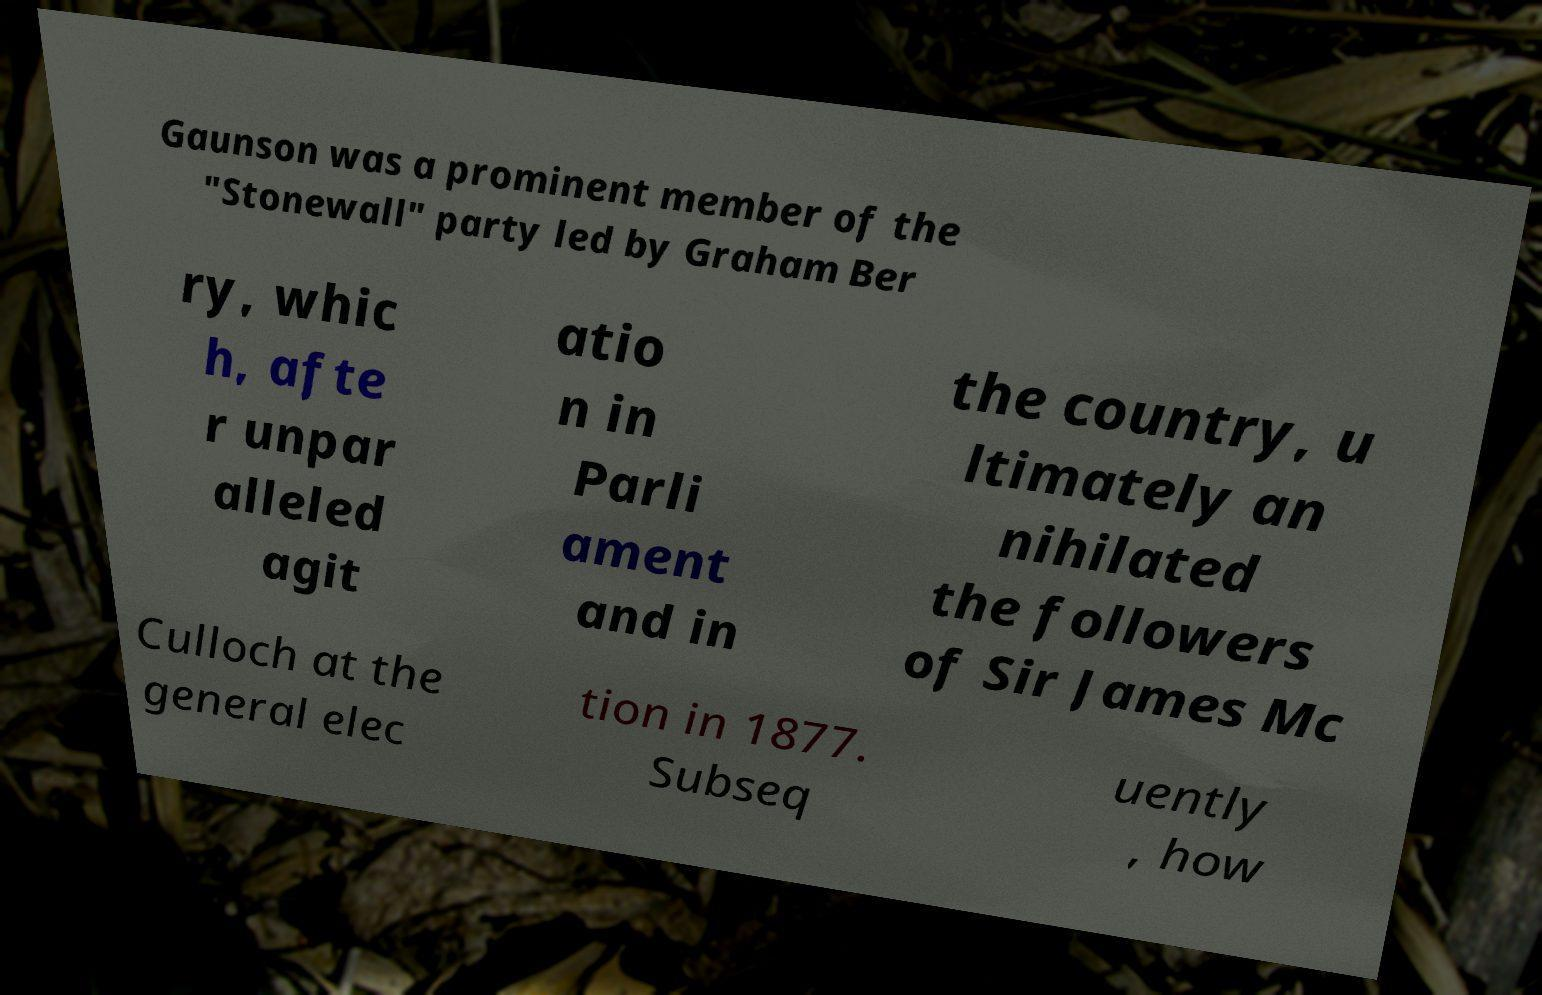Can you read and provide the text displayed in the image?This photo seems to have some interesting text. Can you extract and type it out for me? Gaunson was a prominent member of the "Stonewall" party led by Graham Ber ry, whic h, afte r unpar alleled agit atio n in Parli ament and in the country, u ltimately an nihilated the followers of Sir James Mc Culloch at the general elec tion in 1877. Subseq uently , how 